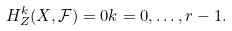<formula> <loc_0><loc_0><loc_500><loc_500>H _ { Z } ^ { k } ( X , \mathcal { F } ) = 0 k = 0 , \dots , r - 1 .</formula> 